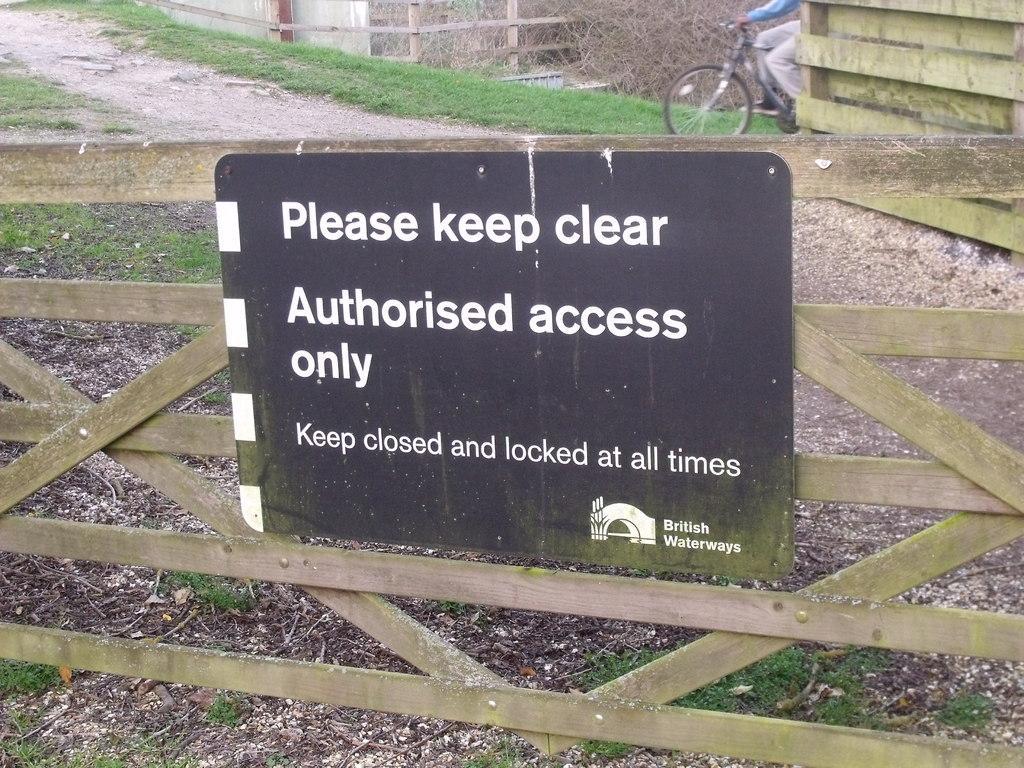How would you summarize this image in a sentence or two? In this image we can see an information board attached to the wooden grill, ground, grass and a person riding the bicycle. 